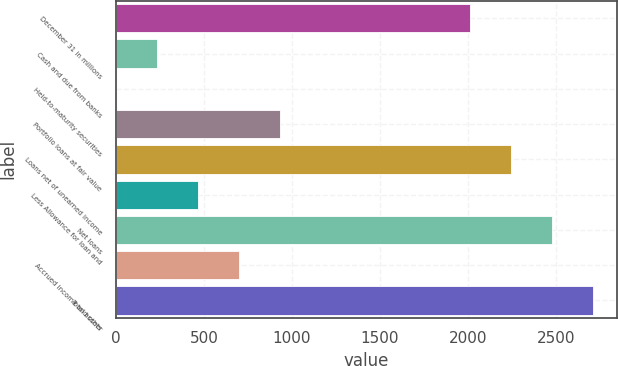<chart> <loc_0><loc_0><loc_500><loc_500><bar_chart><fcel>December 31 in millions<fcel>Cash and due from banks<fcel>Held-to-maturity securities<fcel>Portfolio loans at fair value<fcel>Loans net of unearned income<fcel>Less Allowance for loan and<fcel>Net loans<fcel>Accrued income and other<fcel>Total assets<nl><fcel>2014<fcel>233.3<fcel>1<fcel>930.2<fcel>2246.3<fcel>465.6<fcel>2478.6<fcel>697.9<fcel>2710.9<nl></chart> 